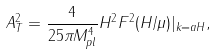Convert formula to latex. <formula><loc_0><loc_0><loc_500><loc_500>A _ { T } ^ { 2 } = \frac { 4 } { 2 5 \pi M _ { p l } ^ { 4 } } H ^ { 2 } F ^ { 2 } ( H / \mu ) | _ { k = a H } ,</formula> 